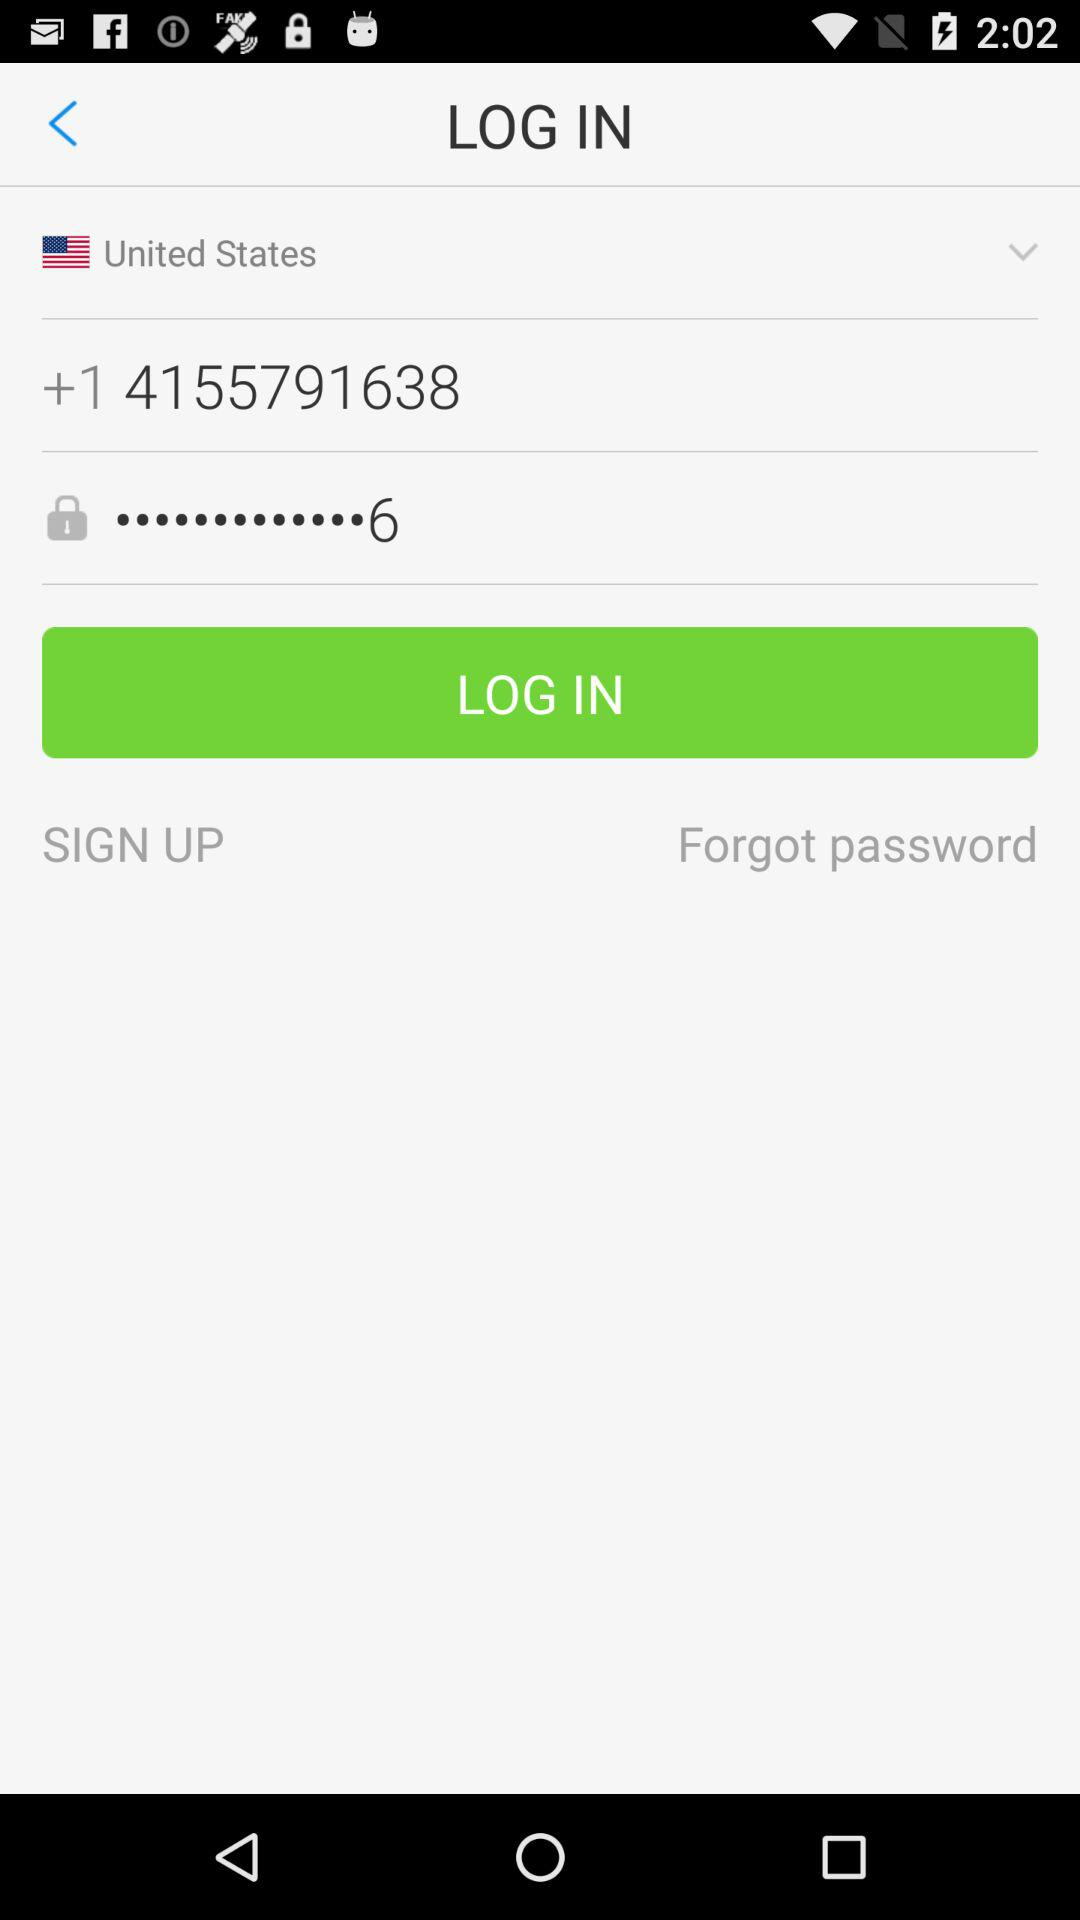What is the contact number? The contact number is +1 4155791638. 